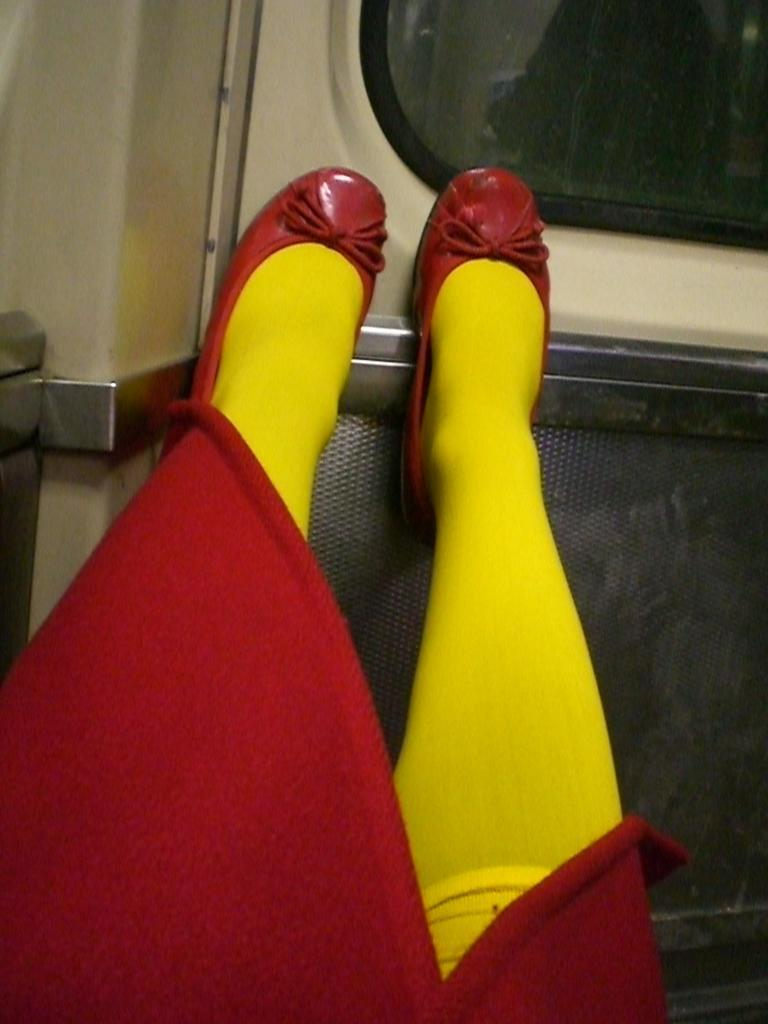What is visible at the front of the image? There are legs of a person in the front of the image. What can be seen in the background of the image? There is a window and a wall in the background of the image. What type of peace treaty is being discussed in the meeting in the image? There is no meeting or peace treaty present in the image; it only shows legs of a person and a background with a window and a wall. 